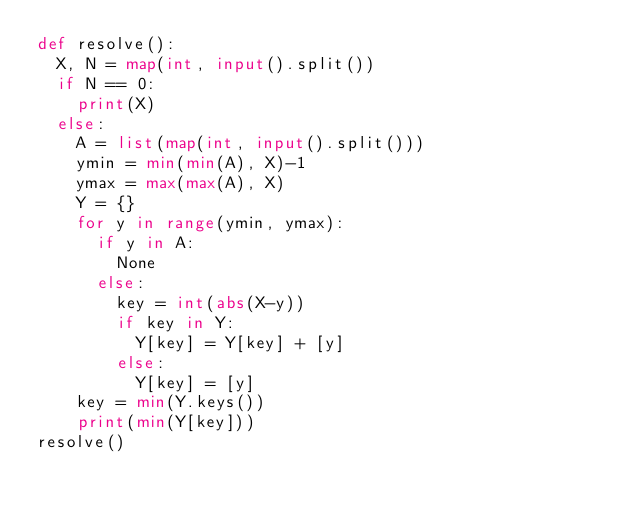<code> <loc_0><loc_0><loc_500><loc_500><_Python_>def resolve():
	X, N = map(int, input().split())
	if N == 0:
		print(X)
	else:
		A = list(map(int, input().split()))
		ymin = min(min(A), X)-1
		ymax = max(max(A), X)
		Y = {}
		for y in range(ymin, ymax):
			if y in A:
				None
			else:
				key = int(abs(X-y))
				if key in Y:
					Y[key] = Y[key] + [y]
				else:
					Y[key] = [y]
		key = min(Y.keys())
		print(min(Y[key]))
resolve()</code> 